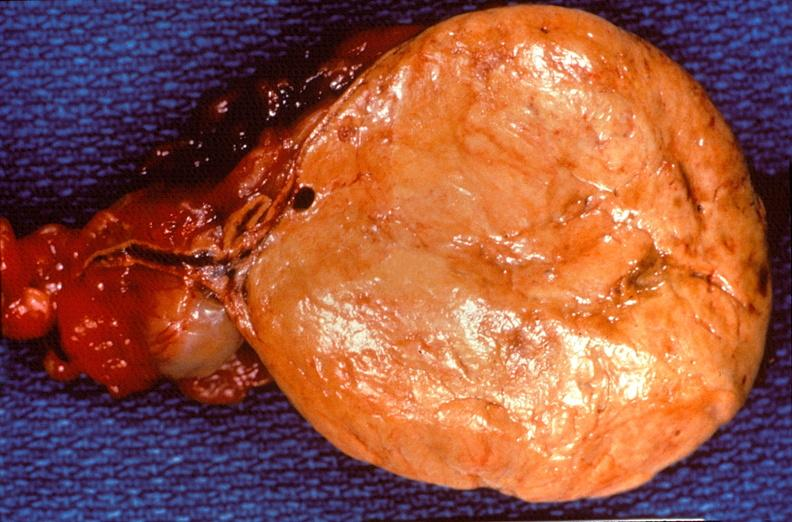where does this belong to?
Answer the question using a single word or phrase. Endocrine system 